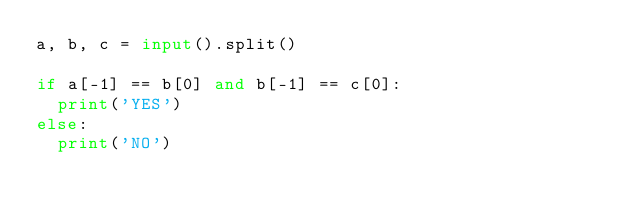<code> <loc_0><loc_0><loc_500><loc_500><_Python_>a, b, c = input().split()

if a[-1] == b[0] and b[-1] == c[0]:
	print('YES')
else:
	print('NO')</code> 